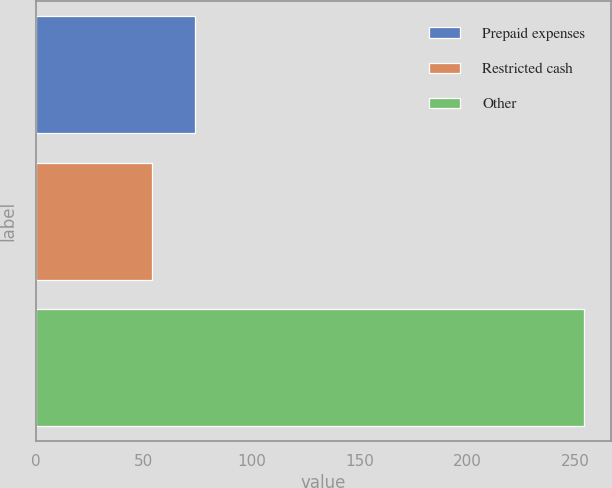Convert chart. <chart><loc_0><loc_0><loc_500><loc_500><bar_chart><fcel>Prepaid expenses<fcel>Restricted cash<fcel>Other<nl><fcel>74<fcel>54<fcel>254<nl></chart> 